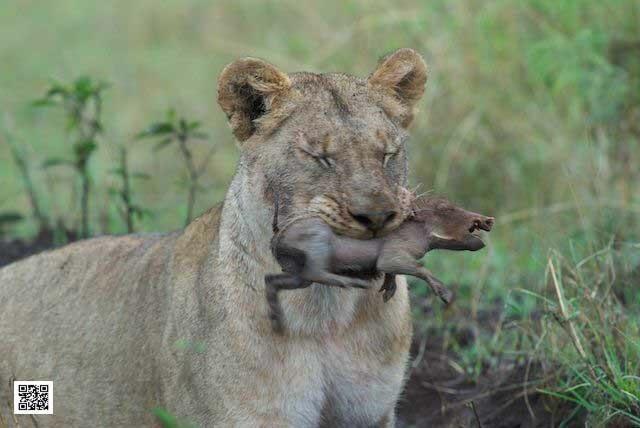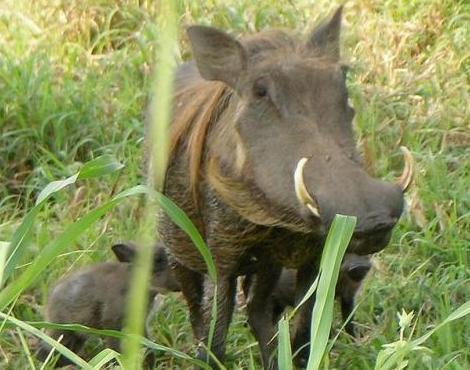The first image is the image on the left, the second image is the image on the right. Considering the images on both sides, is "The combined images show four warthogs and do not show any other mammal." valid? Answer yes or no. No. The first image is the image on the left, the second image is the image on the right. Evaluate the accuracy of this statement regarding the images: "A hog and two baby hogs are grazing in the left picture.". Is it true? Answer yes or no. No. 